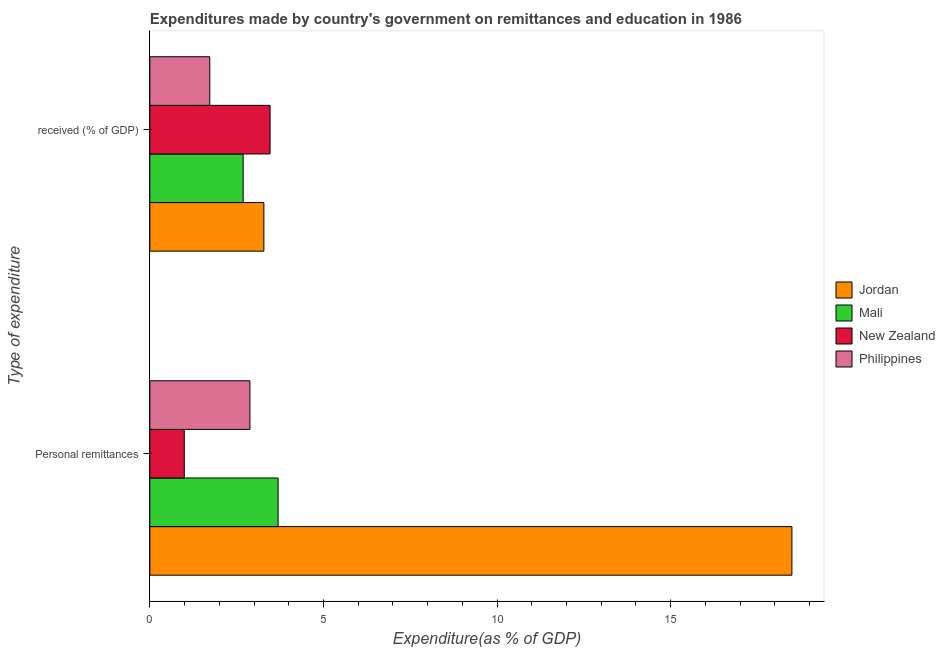How many different coloured bars are there?
Your answer should be compact. 4. Are the number of bars on each tick of the Y-axis equal?
Keep it short and to the point. Yes. How many bars are there on the 1st tick from the top?
Your answer should be compact. 4. How many bars are there on the 2nd tick from the bottom?
Ensure brevity in your answer.  4. What is the label of the 1st group of bars from the top?
Provide a succinct answer.  received (% of GDP). What is the expenditure in personal remittances in Mali?
Offer a terse response. 3.69. Across all countries, what is the maximum expenditure in education?
Give a very brief answer. 3.46. Across all countries, what is the minimum expenditure in education?
Keep it short and to the point. 1.73. In which country was the expenditure in personal remittances maximum?
Keep it short and to the point. Jordan. In which country was the expenditure in personal remittances minimum?
Your answer should be very brief. New Zealand. What is the total expenditure in education in the graph?
Offer a very short reply. 11.16. What is the difference between the expenditure in education in Philippines and that in New Zealand?
Keep it short and to the point. -1.74. What is the difference between the expenditure in education in New Zealand and the expenditure in personal remittances in Jordan?
Offer a very short reply. -15.03. What is the average expenditure in personal remittances per country?
Offer a very short reply. 6.52. What is the difference between the expenditure in personal remittances and expenditure in education in Mali?
Your response must be concise. 1.01. In how many countries, is the expenditure in personal remittances greater than 3 %?
Make the answer very short. 2. What is the ratio of the expenditure in education in Jordan to that in New Zealand?
Provide a short and direct response. 0.95. Is the expenditure in personal remittances in Jordan less than that in Mali?
Your response must be concise. No. In how many countries, is the expenditure in personal remittances greater than the average expenditure in personal remittances taken over all countries?
Provide a succinct answer. 1. What does the 2nd bar from the top in Personal remittances represents?
Make the answer very short. New Zealand. What does the 1st bar from the bottom in  received (% of GDP) represents?
Ensure brevity in your answer.  Jordan. How many bars are there?
Provide a succinct answer. 8. How many countries are there in the graph?
Your response must be concise. 4. What is the difference between two consecutive major ticks on the X-axis?
Your answer should be very brief. 5. Does the graph contain any zero values?
Give a very brief answer. No. How many legend labels are there?
Provide a succinct answer. 4. What is the title of the graph?
Your answer should be compact. Expenditures made by country's government on remittances and education in 1986. Does "Namibia" appear as one of the legend labels in the graph?
Offer a terse response. No. What is the label or title of the X-axis?
Your answer should be compact. Expenditure(as % of GDP). What is the label or title of the Y-axis?
Your answer should be compact. Type of expenditure. What is the Expenditure(as % of GDP) in Jordan in Personal remittances?
Keep it short and to the point. 18.49. What is the Expenditure(as % of GDP) of Mali in Personal remittances?
Your response must be concise. 3.69. What is the Expenditure(as % of GDP) in New Zealand in Personal remittances?
Offer a very short reply. 0.99. What is the Expenditure(as % of GDP) of Philippines in Personal remittances?
Offer a terse response. 2.88. What is the Expenditure(as % of GDP) of Jordan in  received (% of GDP)?
Provide a succinct answer. 3.28. What is the Expenditure(as % of GDP) of Mali in  received (% of GDP)?
Offer a very short reply. 2.69. What is the Expenditure(as % of GDP) of New Zealand in  received (% of GDP)?
Your response must be concise. 3.46. What is the Expenditure(as % of GDP) in Philippines in  received (% of GDP)?
Ensure brevity in your answer.  1.73. Across all Type of expenditure, what is the maximum Expenditure(as % of GDP) of Jordan?
Keep it short and to the point. 18.49. Across all Type of expenditure, what is the maximum Expenditure(as % of GDP) in Mali?
Offer a very short reply. 3.69. Across all Type of expenditure, what is the maximum Expenditure(as % of GDP) in New Zealand?
Offer a very short reply. 3.46. Across all Type of expenditure, what is the maximum Expenditure(as % of GDP) in Philippines?
Make the answer very short. 2.88. Across all Type of expenditure, what is the minimum Expenditure(as % of GDP) of Jordan?
Your response must be concise. 3.28. Across all Type of expenditure, what is the minimum Expenditure(as % of GDP) in Mali?
Make the answer very short. 2.69. Across all Type of expenditure, what is the minimum Expenditure(as % of GDP) in New Zealand?
Your answer should be very brief. 0.99. Across all Type of expenditure, what is the minimum Expenditure(as % of GDP) in Philippines?
Make the answer very short. 1.73. What is the total Expenditure(as % of GDP) of Jordan in the graph?
Your response must be concise. 21.78. What is the total Expenditure(as % of GDP) in Mali in the graph?
Offer a very short reply. 6.38. What is the total Expenditure(as % of GDP) of New Zealand in the graph?
Provide a succinct answer. 4.45. What is the total Expenditure(as % of GDP) in Philippines in the graph?
Offer a terse response. 4.61. What is the difference between the Expenditure(as % of GDP) in Jordan in Personal remittances and that in  received (% of GDP)?
Ensure brevity in your answer.  15.21. What is the difference between the Expenditure(as % of GDP) of Mali in Personal remittances and that in  received (% of GDP)?
Your answer should be compact. 1.01. What is the difference between the Expenditure(as % of GDP) in New Zealand in Personal remittances and that in  received (% of GDP)?
Keep it short and to the point. -2.47. What is the difference between the Expenditure(as % of GDP) of Philippines in Personal remittances and that in  received (% of GDP)?
Provide a short and direct response. 1.16. What is the difference between the Expenditure(as % of GDP) of Jordan in Personal remittances and the Expenditure(as % of GDP) of Mali in  received (% of GDP)?
Offer a terse response. 15.8. What is the difference between the Expenditure(as % of GDP) of Jordan in Personal remittances and the Expenditure(as % of GDP) of New Zealand in  received (% of GDP)?
Make the answer very short. 15.03. What is the difference between the Expenditure(as % of GDP) in Jordan in Personal remittances and the Expenditure(as % of GDP) in Philippines in  received (% of GDP)?
Make the answer very short. 16.77. What is the difference between the Expenditure(as % of GDP) in Mali in Personal remittances and the Expenditure(as % of GDP) in New Zealand in  received (% of GDP)?
Your answer should be compact. 0.23. What is the difference between the Expenditure(as % of GDP) in Mali in Personal remittances and the Expenditure(as % of GDP) in Philippines in  received (% of GDP)?
Keep it short and to the point. 1.97. What is the difference between the Expenditure(as % of GDP) of New Zealand in Personal remittances and the Expenditure(as % of GDP) of Philippines in  received (% of GDP)?
Offer a terse response. -0.73. What is the average Expenditure(as % of GDP) in Jordan per Type of expenditure?
Your answer should be compact. 10.89. What is the average Expenditure(as % of GDP) in Mali per Type of expenditure?
Provide a succinct answer. 3.19. What is the average Expenditure(as % of GDP) in New Zealand per Type of expenditure?
Offer a very short reply. 2.23. What is the average Expenditure(as % of GDP) of Philippines per Type of expenditure?
Keep it short and to the point. 2.3. What is the difference between the Expenditure(as % of GDP) of Jordan and Expenditure(as % of GDP) of Mali in Personal remittances?
Your answer should be compact. 14.8. What is the difference between the Expenditure(as % of GDP) of Jordan and Expenditure(as % of GDP) of New Zealand in Personal remittances?
Keep it short and to the point. 17.5. What is the difference between the Expenditure(as % of GDP) in Jordan and Expenditure(as % of GDP) in Philippines in Personal remittances?
Keep it short and to the point. 15.61. What is the difference between the Expenditure(as % of GDP) of Mali and Expenditure(as % of GDP) of New Zealand in Personal remittances?
Your response must be concise. 2.7. What is the difference between the Expenditure(as % of GDP) in Mali and Expenditure(as % of GDP) in Philippines in Personal remittances?
Ensure brevity in your answer.  0.81. What is the difference between the Expenditure(as % of GDP) in New Zealand and Expenditure(as % of GDP) in Philippines in Personal remittances?
Provide a succinct answer. -1.89. What is the difference between the Expenditure(as % of GDP) of Jordan and Expenditure(as % of GDP) of Mali in  received (% of GDP)?
Your answer should be compact. 0.6. What is the difference between the Expenditure(as % of GDP) of Jordan and Expenditure(as % of GDP) of New Zealand in  received (% of GDP)?
Your answer should be very brief. -0.18. What is the difference between the Expenditure(as % of GDP) in Jordan and Expenditure(as % of GDP) in Philippines in  received (% of GDP)?
Make the answer very short. 1.56. What is the difference between the Expenditure(as % of GDP) of Mali and Expenditure(as % of GDP) of New Zealand in  received (% of GDP)?
Provide a short and direct response. -0.77. What is the difference between the Expenditure(as % of GDP) of Mali and Expenditure(as % of GDP) of Philippines in  received (% of GDP)?
Provide a short and direct response. 0.96. What is the difference between the Expenditure(as % of GDP) of New Zealand and Expenditure(as % of GDP) of Philippines in  received (% of GDP)?
Your answer should be compact. 1.74. What is the ratio of the Expenditure(as % of GDP) of Jordan in Personal remittances to that in  received (% of GDP)?
Ensure brevity in your answer.  5.63. What is the ratio of the Expenditure(as % of GDP) of Mali in Personal remittances to that in  received (% of GDP)?
Keep it short and to the point. 1.37. What is the ratio of the Expenditure(as % of GDP) of New Zealand in Personal remittances to that in  received (% of GDP)?
Keep it short and to the point. 0.29. What is the ratio of the Expenditure(as % of GDP) of Philippines in Personal remittances to that in  received (% of GDP)?
Keep it short and to the point. 1.67. What is the difference between the highest and the second highest Expenditure(as % of GDP) in Jordan?
Your answer should be very brief. 15.21. What is the difference between the highest and the second highest Expenditure(as % of GDP) in Mali?
Offer a terse response. 1.01. What is the difference between the highest and the second highest Expenditure(as % of GDP) of New Zealand?
Provide a short and direct response. 2.47. What is the difference between the highest and the second highest Expenditure(as % of GDP) of Philippines?
Your answer should be very brief. 1.16. What is the difference between the highest and the lowest Expenditure(as % of GDP) in Jordan?
Provide a short and direct response. 15.21. What is the difference between the highest and the lowest Expenditure(as % of GDP) in Mali?
Provide a succinct answer. 1.01. What is the difference between the highest and the lowest Expenditure(as % of GDP) in New Zealand?
Keep it short and to the point. 2.47. What is the difference between the highest and the lowest Expenditure(as % of GDP) of Philippines?
Offer a terse response. 1.16. 